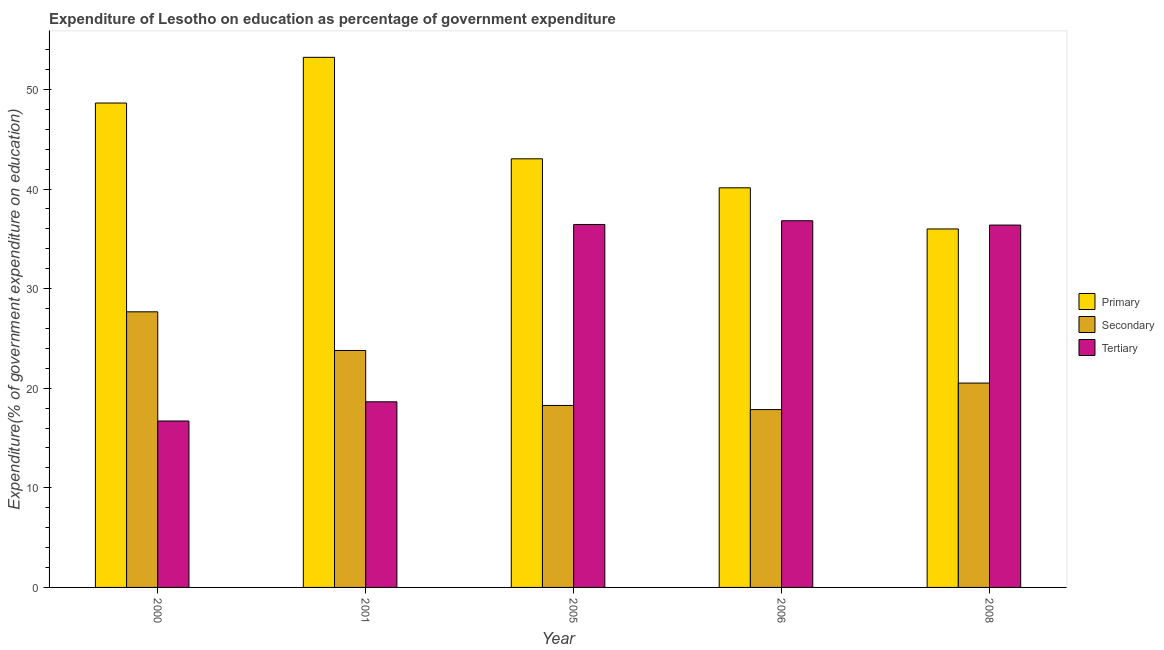Are the number of bars per tick equal to the number of legend labels?
Your answer should be very brief. Yes. In how many cases, is the number of bars for a given year not equal to the number of legend labels?
Your answer should be compact. 0. What is the expenditure on primary education in 2008?
Keep it short and to the point. 35.99. Across all years, what is the maximum expenditure on secondary education?
Keep it short and to the point. 27.67. Across all years, what is the minimum expenditure on tertiary education?
Give a very brief answer. 16.71. What is the total expenditure on tertiary education in the graph?
Make the answer very short. 145. What is the difference between the expenditure on tertiary education in 2001 and that in 2005?
Keep it short and to the point. -17.81. What is the difference between the expenditure on primary education in 2000 and the expenditure on secondary education in 2005?
Ensure brevity in your answer.  5.6. What is the average expenditure on primary education per year?
Keep it short and to the point. 44.2. In the year 2005, what is the difference between the expenditure on secondary education and expenditure on primary education?
Give a very brief answer. 0. In how many years, is the expenditure on primary education greater than 24 %?
Give a very brief answer. 5. What is the ratio of the expenditure on primary education in 2000 to that in 2006?
Your answer should be compact. 1.21. Is the expenditure on tertiary education in 2000 less than that in 2008?
Offer a very short reply. Yes. Is the difference between the expenditure on tertiary education in 2000 and 2006 greater than the difference between the expenditure on secondary education in 2000 and 2006?
Your answer should be very brief. No. What is the difference between the highest and the second highest expenditure on tertiary education?
Give a very brief answer. 0.37. What is the difference between the highest and the lowest expenditure on primary education?
Provide a succinct answer. 17.23. What does the 3rd bar from the left in 2006 represents?
Your answer should be compact. Tertiary. What does the 2nd bar from the right in 2001 represents?
Offer a very short reply. Secondary. How many years are there in the graph?
Make the answer very short. 5. Does the graph contain grids?
Offer a terse response. No. How many legend labels are there?
Keep it short and to the point. 3. How are the legend labels stacked?
Give a very brief answer. Vertical. What is the title of the graph?
Give a very brief answer. Expenditure of Lesotho on education as percentage of government expenditure. Does "Errors" appear as one of the legend labels in the graph?
Keep it short and to the point. No. What is the label or title of the X-axis?
Your answer should be compact. Year. What is the label or title of the Y-axis?
Offer a terse response. Expenditure(% of government expenditure on education). What is the Expenditure(% of government expenditure on education) in Primary in 2000?
Provide a succinct answer. 48.64. What is the Expenditure(% of government expenditure on education) in Secondary in 2000?
Provide a succinct answer. 27.67. What is the Expenditure(% of government expenditure on education) of Tertiary in 2000?
Your answer should be compact. 16.71. What is the Expenditure(% of government expenditure on education) of Primary in 2001?
Your answer should be compact. 53.23. What is the Expenditure(% of government expenditure on education) in Secondary in 2001?
Offer a terse response. 23.79. What is the Expenditure(% of government expenditure on education) of Tertiary in 2001?
Your answer should be compact. 18.64. What is the Expenditure(% of government expenditure on education) of Primary in 2005?
Offer a very short reply. 43.04. What is the Expenditure(% of government expenditure on education) in Secondary in 2005?
Keep it short and to the point. 18.27. What is the Expenditure(% of government expenditure on education) of Tertiary in 2005?
Provide a short and direct response. 36.44. What is the Expenditure(% of government expenditure on education) of Primary in 2006?
Offer a very short reply. 40.12. What is the Expenditure(% of government expenditure on education) of Secondary in 2006?
Keep it short and to the point. 17.86. What is the Expenditure(% of government expenditure on education) in Tertiary in 2006?
Your answer should be very brief. 36.82. What is the Expenditure(% of government expenditure on education) of Primary in 2008?
Offer a terse response. 35.99. What is the Expenditure(% of government expenditure on education) of Secondary in 2008?
Ensure brevity in your answer.  20.52. What is the Expenditure(% of government expenditure on education) of Tertiary in 2008?
Your answer should be compact. 36.38. Across all years, what is the maximum Expenditure(% of government expenditure on education) in Primary?
Give a very brief answer. 53.23. Across all years, what is the maximum Expenditure(% of government expenditure on education) of Secondary?
Give a very brief answer. 27.67. Across all years, what is the maximum Expenditure(% of government expenditure on education) in Tertiary?
Your response must be concise. 36.82. Across all years, what is the minimum Expenditure(% of government expenditure on education) in Primary?
Give a very brief answer. 35.99. Across all years, what is the minimum Expenditure(% of government expenditure on education) in Secondary?
Your answer should be compact. 17.86. Across all years, what is the minimum Expenditure(% of government expenditure on education) of Tertiary?
Offer a very short reply. 16.71. What is the total Expenditure(% of government expenditure on education) of Primary in the graph?
Offer a very short reply. 221.02. What is the total Expenditure(% of government expenditure on education) of Secondary in the graph?
Ensure brevity in your answer.  108.11. What is the total Expenditure(% of government expenditure on education) of Tertiary in the graph?
Your response must be concise. 145. What is the difference between the Expenditure(% of government expenditure on education) in Primary in 2000 and that in 2001?
Make the answer very short. -4.59. What is the difference between the Expenditure(% of government expenditure on education) of Secondary in 2000 and that in 2001?
Your response must be concise. 3.88. What is the difference between the Expenditure(% of government expenditure on education) in Tertiary in 2000 and that in 2001?
Your response must be concise. -1.93. What is the difference between the Expenditure(% of government expenditure on education) in Primary in 2000 and that in 2005?
Keep it short and to the point. 5.6. What is the difference between the Expenditure(% of government expenditure on education) in Secondary in 2000 and that in 2005?
Your response must be concise. 9.4. What is the difference between the Expenditure(% of government expenditure on education) in Tertiary in 2000 and that in 2005?
Keep it short and to the point. -19.73. What is the difference between the Expenditure(% of government expenditure on education) of Primary in 2000 and that in 2006?
Ensure brevity in your answer.  8.51. What is the difference between the Expenditure(% of government expenditure on education) of Secondary in 2000 and that in 2006?
Your answer should be very brief. 9.82. What is the difference between the Expenditure(% of government expenditure on education) in Tertiary in 2000 and that in 2006?
Make the answer very short. -20.11. What is the difference between the Expenditure(% of government expenditure on education) in Primary in 2000 and that in 2008?
Provide a short and direct response. 12.64. What is the difference between the Expenditure(% of government expenditure on education) in Secondary in 2000 and that in 2008?
Provide a short and direct response. 7.15. What is the difference between the Expenditure(% of government expenditure on education) of Tertiary in 2000 and that in 2008?
Your response must be concise. -19.67. What is the difference between the Expenditure(% of government expenditure on education) in Primary in 2001 and that in 2005?
Provide a short and direct response. 10.19. What is the difference between the Expenditure(% of government expenditure on education) of Secondary in 2001 and that in 2005?
Make the answer very short. 5.52. What is the difference between the Expenditure(% of government expenditure on education) of Tertiary in 2001 and that in 2005?
Ensure brevity in your answer.  -17.81. What is the difference between the Expenditure(% of government expenditure on education) of Primary in 2001 and that in 2006?
Offer a very short reply. 13.1. What is the difference between the Expenditure(% of government expenditure on education) in Secondary in 2001 and that in 2006?
Your response must be concise. 5.94. What is the difference between the Expenditure(% of government expenditure on education) of Tertiary in 2001 and that in 2006?
Make the answer very short. -18.18. What is the difference between the Expenditure(% of government expenditure on education) in Primary in 2001 and that in 2008?
Ensure brevity in your answer.  17.23. What is the difference between the Expenditure(% of government expenditure on education) of Secondary in 2001 and that in 2008?
Ensure brevity in your answer.  3.27. What is the difference between the Expenditure(% of government expenditure on education) of Tertiary in 2001 and that in 2008?
Keep it short and to the point. -17.75. What is the difference between the Expenditure(% of government expenditure on education) in Primary in 2005 and that in 2006?
Provide a succinct answer. 2.91. What is the difference between the Expenditure(% of government expenditure on education) of Secondary in 2005 and that in 2006?
Make the answer very short. 0.42. What is the difference between the Expenditure(% of government expenditure on education) in Tertiary in 2005 and that in 2006?
Your response must be concise. -0.37. What is the difference between the Expenditure(% of government expenditure on education) in Primary in 2005 and that in 2008?
Offer a terse response. 7.04. What is the difference between the Expenditure(% of government expenditure on education) of Secondary in 2005 and that in 2008?
Offer a terse response. -2.25. What is the difference between the Expenditure(% of government expenditure on education) of Tertiary in 2005 and that in 2008?
Keep it short and to the point. 0.06. What is the difference between the Expenditure(% of government expenditure on education) of Primary in 2006 and that in 2008?
Keep it short and to the point. 4.13. What is the difference between the Expenditure(% of government expenditure on education) of Secondary in 2006 and that in 2008?
Give a very brief answer. -2.66. What is the difference between the Expenditure(% of government expenditure on education) of Tertiary in 2006 and that in 2008?
Provide a short and direct response. 0.43. What is the difference between the Expenditure(% of government expenditure on education) in Primary in 2000 and the Expenditure(% of government expenditure on education) in Secondary in 2001?
Provide a succinct answer. 24.85. What is the difference between the Expenditure(% of government expenditure on education) in Primary in 2000 and the Expenditure(% of government expenditure on education) in Tertiary in 2001?
Your answer should be compact. 30. What is the difference between the Expenditure(% of government expenditure on education) in Secondary in 2000 and the Expenditure(% of government expenditure on education) in Tertiary in 2001?
Your response must be concise. 9.04. What is the difference between the Expenditure(% of government expenditure on education) of Primary in 2000 and the Expenditure(% of government expenditure on education) of Secondary in 2005?
Ensure brevity in your answer.  30.37. What is the difference between the Expenditure(% of government expenditure on education) in Primary in 2000 and the Expenditure(% of government expenditure on education) in Tertiary in 2005?
Make the answer very short. 12.19. What is the difference between the Expenditure(% of government expenditure on education) of Secondary in 2000 and the Expenditure(% of government expenditure on education) of Tertiary in 2005?
Keep it short and to the point. -8.77. What is the difference between the Expenditure(% of government expenditure on education) of Primary in 2000 and the Expenditure(% of government expenditure on education) of Secondary in 2006?
Provide a short and direct response. 30.78. What is the difference between the Expenditure(% of government expenditure on education) of Primary in 2000 and the Expenditure(% of government expenditure on education) of Tertiary in 2006?
Keep it short and to the point. 11.82. What is the difference between the Expenditure(% of government expenditure on education) of Secondary in 2000 and the Expenditure(% of government expenditure on education) of Tertiary in 2006?
Make the answer very short. -9.14. What is the difference between the Expenditure(% of government expenditure on education) of Primary in 2000 and the Expenditure(% of government expenditure on education) of Secondary in 2008?
Your answer should be very brief. 28.12. What is the difference between the Expenditure(% of government expenditure on education) of Primary in 2000 and the Expenditure(% of government expenditure on education) of Tertiary in 2008?
Your response must be concise. 12.25. What is the difference between the Expenditure(% of government expenditure on education) of Secondary in 2000 and the Expenditure(% of government expenditure on education) of Tertiary in 2008?
Ensure brevity in your answer.  -8.71. What is the difference between the Expenditure(% of government expenditure on education) in Primary in 2001 and the Expenditure(% of government expenditure on education) in Secondary in 2005?
Provide a succinct answer. 34.95. What is the difference between the Expenditure(% of government expenditure on education) in Primary in 2001 and the Expenditure(% of government expenditure on education) in Tertiary in 2005?
Provide a succinct answer. 16.78. What is the difference between the Expenditure(% of government expenditure on education) of Secondary in 2001 and the Expenditure(% of government expenditure on education) of Tertiary in 2005?
Your response must be concise. -12.65. What is the difference between the Expenditure(% of government expenditure on education) in Primary in 2001 and the Expenditure(% of government expenditure on education) in Secondary in 2006?
Your response must be concise. 35.37. What is the difference between the Expenditure(% of government expenditure on education) in Primary in 2001 and the Expenditure(% of government expenditure on education) in Tertiary in 2006?
Your answer should be very brief. 16.41. What is the difference between the Expenditure(% of government expenditure on education) of Secondary in 2001 and the Expenditure(% of government expenditure on education) of Tertiary in 2006?
Ensure brevity in your answer.  -13.03. What is the difference between the Expenditure(% of government expenditure on education) of Primary in 2001 and the Expenditure(% of government expenditure on education) of Secondary in 2008?
Your response must be concise. 32.71. What is the difference between the Expenditure(% of government expenditure on education) in Primary in 2001 and the Expenditure(% of government expenditure on education) in Tertiary in 2008?
Keep it short and to the point. 16.84. What is the difference between the Expenditure(% of government expenditure on education) of Secondary in 2001 and the Expenditure(% of government expenditure on education) of Tertiary in 2008?
Your response must be concise. -12.59. What is the difference between the Expenditure(% of government expenditure on education) of Primary in 2005 and the Expenditure(% of government expenditure on education) of Secondary in 2006?
Keep it short and to the point. 25.18. What is the difference between the Expenditure(% of government expenditure on education) in Primary in 2005 and the Expenditure(% of government expenditure on education) in Tertiary in 2006?
Offer a terse response. 6.22. What is the difference between the Expenditure(% of government expenditure on education) of Secondary in 2005 and the Expenditure(% of government expenditure on education) of Tertiary in 2006?
Ensure brevity in your answer.  -18.55. What is the difference between the Expenditure(% of government expenditure on education) in Primary in 2005 and the Expenditure(% of government expenditure on education) in Secondary in 2008?
Offer a very short reply. 22.52. What is the difference between the Expenditure(% of government expenditure on education) in Primary in 2005 and the Expenditure(% of government expenditure on education) in Tertiary in 2008?
Ensure brevity in your answer.  6.65. What is the difference between the Expenditure(% of government expenditure on education) in Secondary in 2005 and the Expenditure(% of government expenditure on education) in Tertiary in 2008?
Give a very brief answer. -18.11. What is the difference between the Expenditure(% of government expenditure on education) in Primary in 2006 and the Expenditure(% of government expenditure on education) in Secondary in 2008?
Ensure brevity in your answer.  19.6. What is the difference between the Expenditure(% of government expenditure on education) of Primary in 2006 and the Expenditure(% of government expenditure on education) of Tertiary in 2008?
Ensure brevity in your answer.  3.74. What is the difference between the Expenditure(% of government expenditure on education) of Secondary in 2006 and the Expenditure(% of government expenditure on education) of Tertiary in 2008?
Offer a terse response. -18.53. What is the average Expenditure(% of government expenditure on education) in Primary per year?
Give a very brief answer. 44.2. What is the average Expenditure(% of government expenditure on education) in Secondary per year?
Provide a succinct answer. 21.62. What is the average Expenditure(% of government expenditure on education) of Tertiary per year?
Provide a short and direct response. 29. In the year 2000, what is the difference between the Expenditure(% of government expenditure on education) of Primary and Expenditure(% of government expenditure on education) of Secondary?
Ensure brevity in your answer.  20.96. In the year 2000, what is the difference between the Expenditure(% of government expenditure on education) of Primary and Expenditure(% of government expenditure on education) of Tertiary?
Ensure brevity in your answer.  31.93. In the year 2000, what is the difference between the Expenditure(% of government expenditure on education) of Secondary and Expenditure(% of government expenditure on education) of Tertiary?
Offer a terse response. 10.96. In the year 2001, what is the difference between the Expenditure(% of government expenditure on education) of Primary and Expenditure(% of government expenditure on education) of Secondary?
Make the answer very short. 29.44. In the year 2001, what is the difference between the Expenditure(% of government expenditure on education) of Primary and Expenditure(% of government expenditure on education) of Tertiary?
Ensure brevity in your answer.  34.59. In the year 2001, what is the difference between the Expenditure(% of government expenditure on education) in Secondary and Expenditure(% of government expenditure on education) in Tertiary?
Offer a terse response. 5.15. In the year 2005, what is the difference between the Expenditure(% of government expenditure on education) in Primary and Expenditure(% of government expenditure on education) in Secondary?
Your answer should be very brief. 24.76. In the year 2005, what is the difference between the Expenditure(% of government expenditure on education) in Primary and Expenditure(% of government expenditure on education) in Tertiary?
Give a very brief answer. 6.59. In the year 2005, what is the difference between the Expenditure(% of government expenditure on education) in Secondary and Expenditure(% of government expenditure on education) in Tertiary?
Make the answer very short. -18.17. In the year 2006, what is the difference between the Expenditure(% of government expenditure on education) of Primary and Expenditure(% of government expenditure on education) of Secondary?
Your response must be concise. 22.27. In the year 2006, what is the difference between the Expenditure(% of government expenditure on education) in Primary and Expenditure(% of government expenditure on education) in Tertiary?
Your response must be concise. 3.31. In the year 2006, what is the difference between the Expenditure(% of government expenditure on education) of Secondary and Expenditure(% of government expenditure on education) of Tertiary?
Give a very brief answer. -18.96. In the year 2008, what is the difference between the Expenditure(% of government expenditure on education) in Primary and Expenditure(% of government expenditure on education) in Secondary?
Offer a terse response. 15.47. In the year 2008, what is the difference between the Expenditure(% of government expenditure on education) of Primary and Expenditure(% of government expenditure on education) of Tertiary?
Make the answer very short. -0.39. In the year 2008, what is the difference between the Expenditure(% of government expenditure on education) in Secondary and Expenditure(% of government expenditure on education) in Tertiary?
Your answer should be very brief. -15.86. What is the ratio of the Expenditure(% of government expenditure on education) of Primary in 2000 to that in 2001?
Give a very brief answer. 0.91. What is the ratio of the Expenditure(% of government expenditure on education) of Secondary in 2000 to that in 2001?
Offer a very short reply. 1.16. What is the ratio of the Expenditure(% of government expenditure on education) in Tertiary in 2000 to that in 2001?
Ensure brevity in your answer.  0.9. What is the ratio of the Expenditure(% of government expenditure on education) of Primary in 2000 to that in 2005?
Make the answer very short. 1.13. What is the ratio of the Expenditure(% of government expenditure on education) in Secondary in 2000 to that in 2005?
Your response must be concise. 1.51. What is the ratio of the Expenditure(% of government expenditure on education) in Tertiary in 2000 to that in 2005?
Keep it short and to the point. 0.46. What is the ratio of the Expenditure(% of government expenditure on education) in Primary in 2000 to that in 2006?
Your answer should be compact. 1.21. What is the ratio of the Expenditure(% of government expenditure on education) of Secondary in 2000 to that in 2006?
Your answer should be compact. 1.55. What is the ratio of the Expenditure(% of government expenditure on education) in Tertiary in 2000 to that in 2006?
Provide a succinct answer. 0.45. What is the ratio of the Expenditure(% of government expenditure on education) in Primary in 2000 to that in 2008?
Offer a very short reply. 1.35. What is the ratio of the Expenditure(% of government expenditure on education) in Secondary in 2000 to that in 2008?
Give a very brief answer. 1.35. What is the ratio of the Expenditure(% of government expenditure on education) in Tertiary in 2000 to that in 2008?
Provide a short and direct response. 0.46. What is the ratio of the Expenditure(% of government expenditure on education) in Primary in 2001 to that in 2005?
Provide a succinct answer. 1.24. What is the ratio of the Expenditure(% of government expenditure on education) of Secondary in 2001 to that in 2005?
Make the answer very short. 1.3. What is the ratio of the Expenditure(% of government expenditure on education) of Tertiary in 2001 to that in 2005?
Your answer should be compact. 0.51. What is the ratio of the Expenditure(% of government expenditure on education) of Primary in 2001 to that in 2006?
Your response must be concise. 1.33. What is the ratio of the Expenditure(% of government expenditure on education) of Secondary in 2001 to that in 2006?
Offer a very short reply. 1.33. What is the ratio of the Expenditure(% of government expenditure on education) in Tertiary in 2001 to that in 2006?
Offer a terse response. 0.51. What is the ratio of the Expenditure(% of government expenditure on education) in Primary in 2001 to that in 2008?
Your answer should be very brief. 1.48. What is the ratio of the Expenditure(% of government expenditure on education) of Secondary in 2001 to that in 2008?
Offer a very short reply. 1.16. What is the ratio of the Expenditure(% of government expenditure on education) of Tertiary in 2001 to that in 2008?
Your response must be concise. 0.51. What is the ratio of the Expenditure(% of government expenditure on education) of Primary in 2005 to that in 2006?
Give a very brief answer. 1.07. What is the ratio of the Expenditure(% of government expenditure on education) of Secondary in 2005 to that in 2006?
Provide a short and direct response. 1.02. What is the ratio of the Expenditure(% of government expenditure on education) in Tertiary in 2005 to that in 2006?
Make the answer very short. 0.99. What is the ratio of the Expenditure(% of government expenditure on education) of Primary in 2005 to that in 2008?
Ensure brevity in your answer.  1.2. What is the ratio of the Expenditure(% of government expenditure on education) in Secondary in 2005 to that in 2008?
Provide a succinct answer. 0.89. What is the ratio of the Expenditure(% of government expenditure on education) in Tertiary in 2005 to that in 2008?
Give a very brief answer. 1. What is the ratio of the Expenditure(% of government expenditure on education) in Primary in 2006 to that in 2008?
Offer a very short reply. 1.11. What is the ratio of the Expenditure(% of government expenditure on education) of Secondary in 2006 to that in 2008?
Offer a very short reply. 0.87. What is the ratio of the Expenditure(% of government expenditure on education) of Tertiary in 2006 to that in 2008?
Your response must be concise. 1.01. What is the difference between the highest and the second highest Expenditure(% of government expenditure on education) in Primary?
Your answer should be compact. 4.59. What is the difference between the highest and the second highest Expenditure(% of government expenditure on education) in Secondary?
Your answer should be compact. 3.88. What is the difference between the highest and the second highest Expenditure(% of government expenditure on education) of Tertiary?
Your answer should be very brief. 0.37. What is the difference between the highest and the lowest Expenditure(% of government expenditure on education) in Primary?
Make the answer very short. 17.23. What is the difference between the highest and the lowest Expenditure(% of government expenditure on education) of Secondary?
Provide a succinct answer. 9.82. What is the difference between the highest and the lowest Expenditure(% of government expenditure on education) of Tertiary?
Make the answer very short. 20.11. 